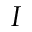Convert formula to latex. <formula><loc_0><loc_0><loc_500><loc_500>I</formula> 